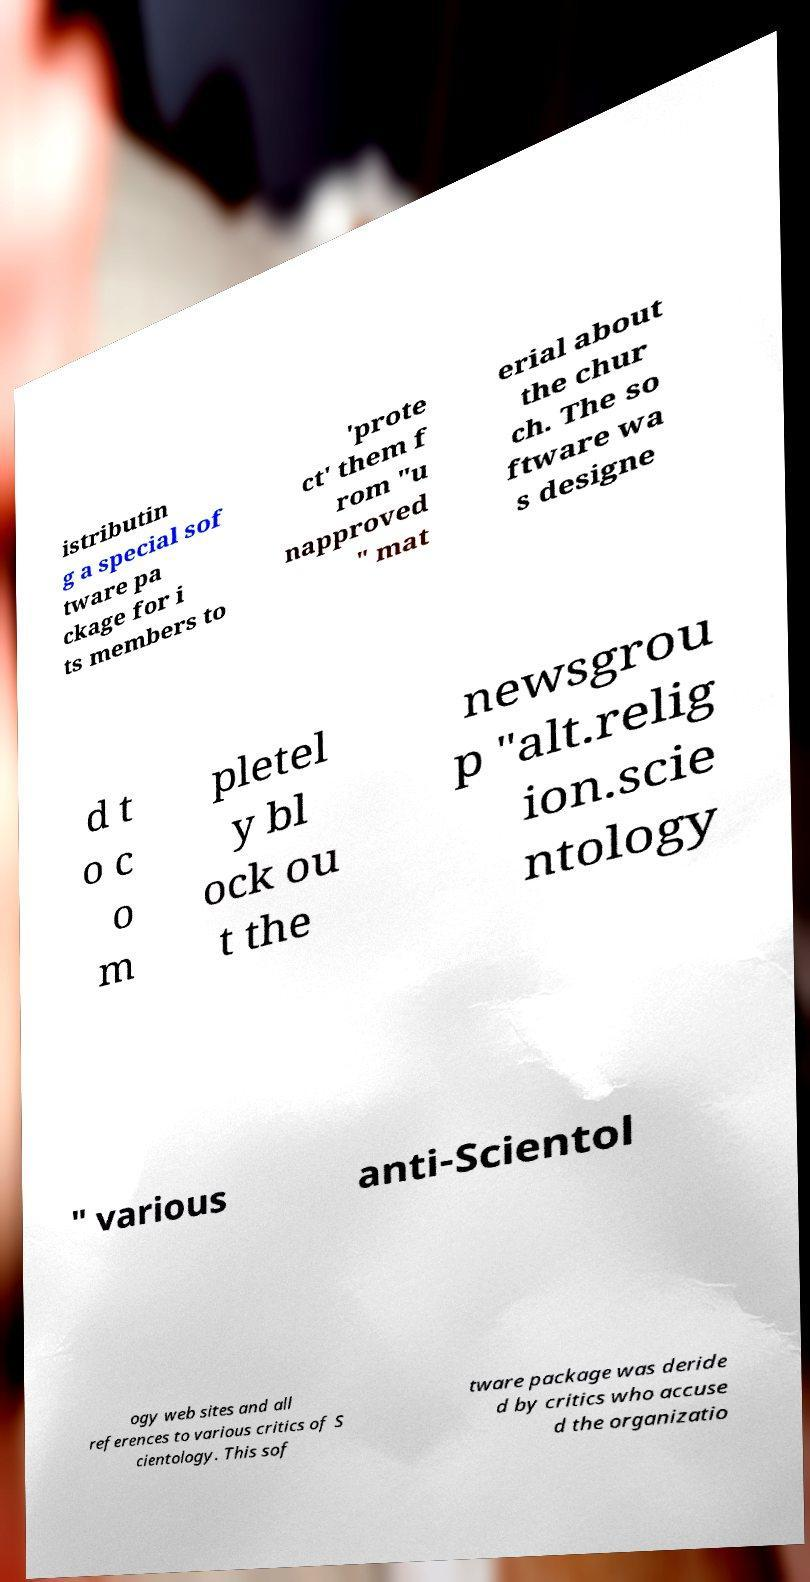Can you read and provide the text displayed in the image?This photo seems to have some interesting text. Can you extract and type it out for me? istributin g a special sof tware pa ckage for i ts members to 'prote ct' them f rom "u napproved " mat erial about the chur ch. The so ftware wa s designe d t o c o m pletel y bl ock ou t the newsgrou p "alt.relig ion.scie ntology " various anti-Scientol ogy web sites and all references to various critics of S cientology. This sof tware package was deride d by critics who accuse d the organizatio 